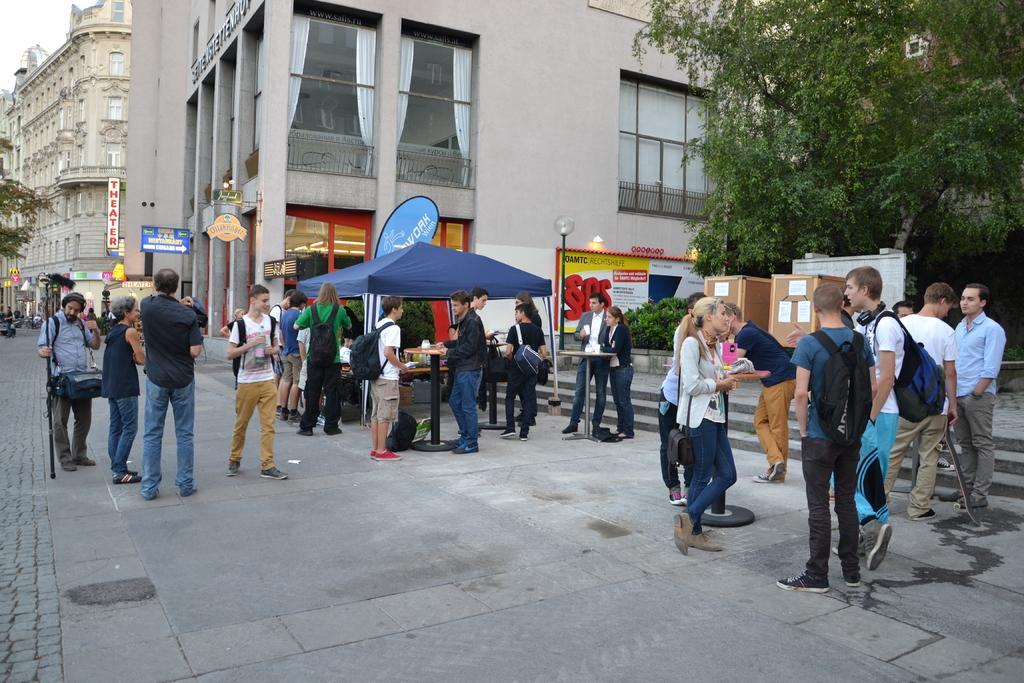How would you summarize this image in a sentence or two? In this picture, I can see buildings, trees and few boards with some text and I can see few people standing and a human walking. I can see a tent, few tables and couple of wooden boxes on the right side and couple of curtains to the glass window. 